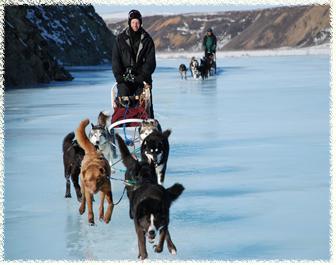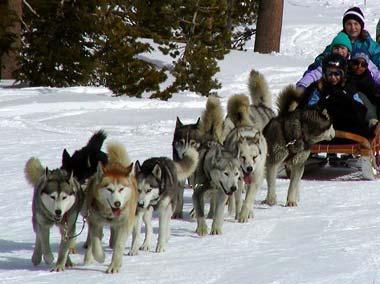The first image is the image on the left, the second image is the image on the right. Analyze the images presented: Is the assertion "Three separate teams of sled dogs are harnessed." valid? Answer yes or no. Yes. The first image is the image on the left, the second image is the image on the right. Evaluate the accuracy of this statement regarding the images: "There are at least three humans in the right image.". Is it true? Answer yes or no. Yes. The first image is the image on the left, the second image is the image on the right. Examine the images to the left and right. Is the description "An image shows a team of sled dogs wearing matching booties." accurate? Answer yes or no. No. The first image is the image on the left, the second image is the image on the right. Evaluate the accuracy of this statement regarding the images: "No mountains are visible behind the sleds in the right image.". Is it true? Answer yes or no. Yes. The first image is the image on the left, the second image is the image on the right. Analyze the images presented: Is the assertion "A person in a red and black jacket is in the foreground of one image." valid? Answer yes or no. No. 